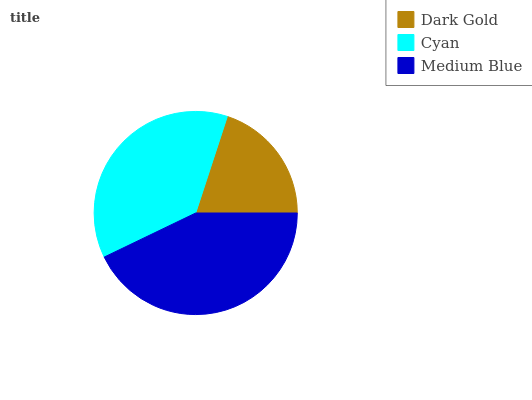Is Dark Gold the minimum?
Answer yes or no. Yes. Is Medium Blue the maximum?
Answer yes or no. Yes. Is Cyan the minimum?
Answer yes or no. No. Is Cyan the maximum?
Answer yes or no. No. Is Cyan greater than Dark Gold?
Answer yes or no. Yes. Is Dark Gold less than Cyan?
Answer yes or no. Yes. Is Dark Gold greater than Cyan?
Answer yes or no. No. Is Cyan less than Dark Gold?
Answer yes or no. No. Is Cyan the high median?
Answer yes or no. Yes. Is Cyan the low median?
Answer yes or no. Yes. Is Dark Gold the high median?
Answer yes or no. No. Is Medium Blue the low median?
Answer yes or no. No. 